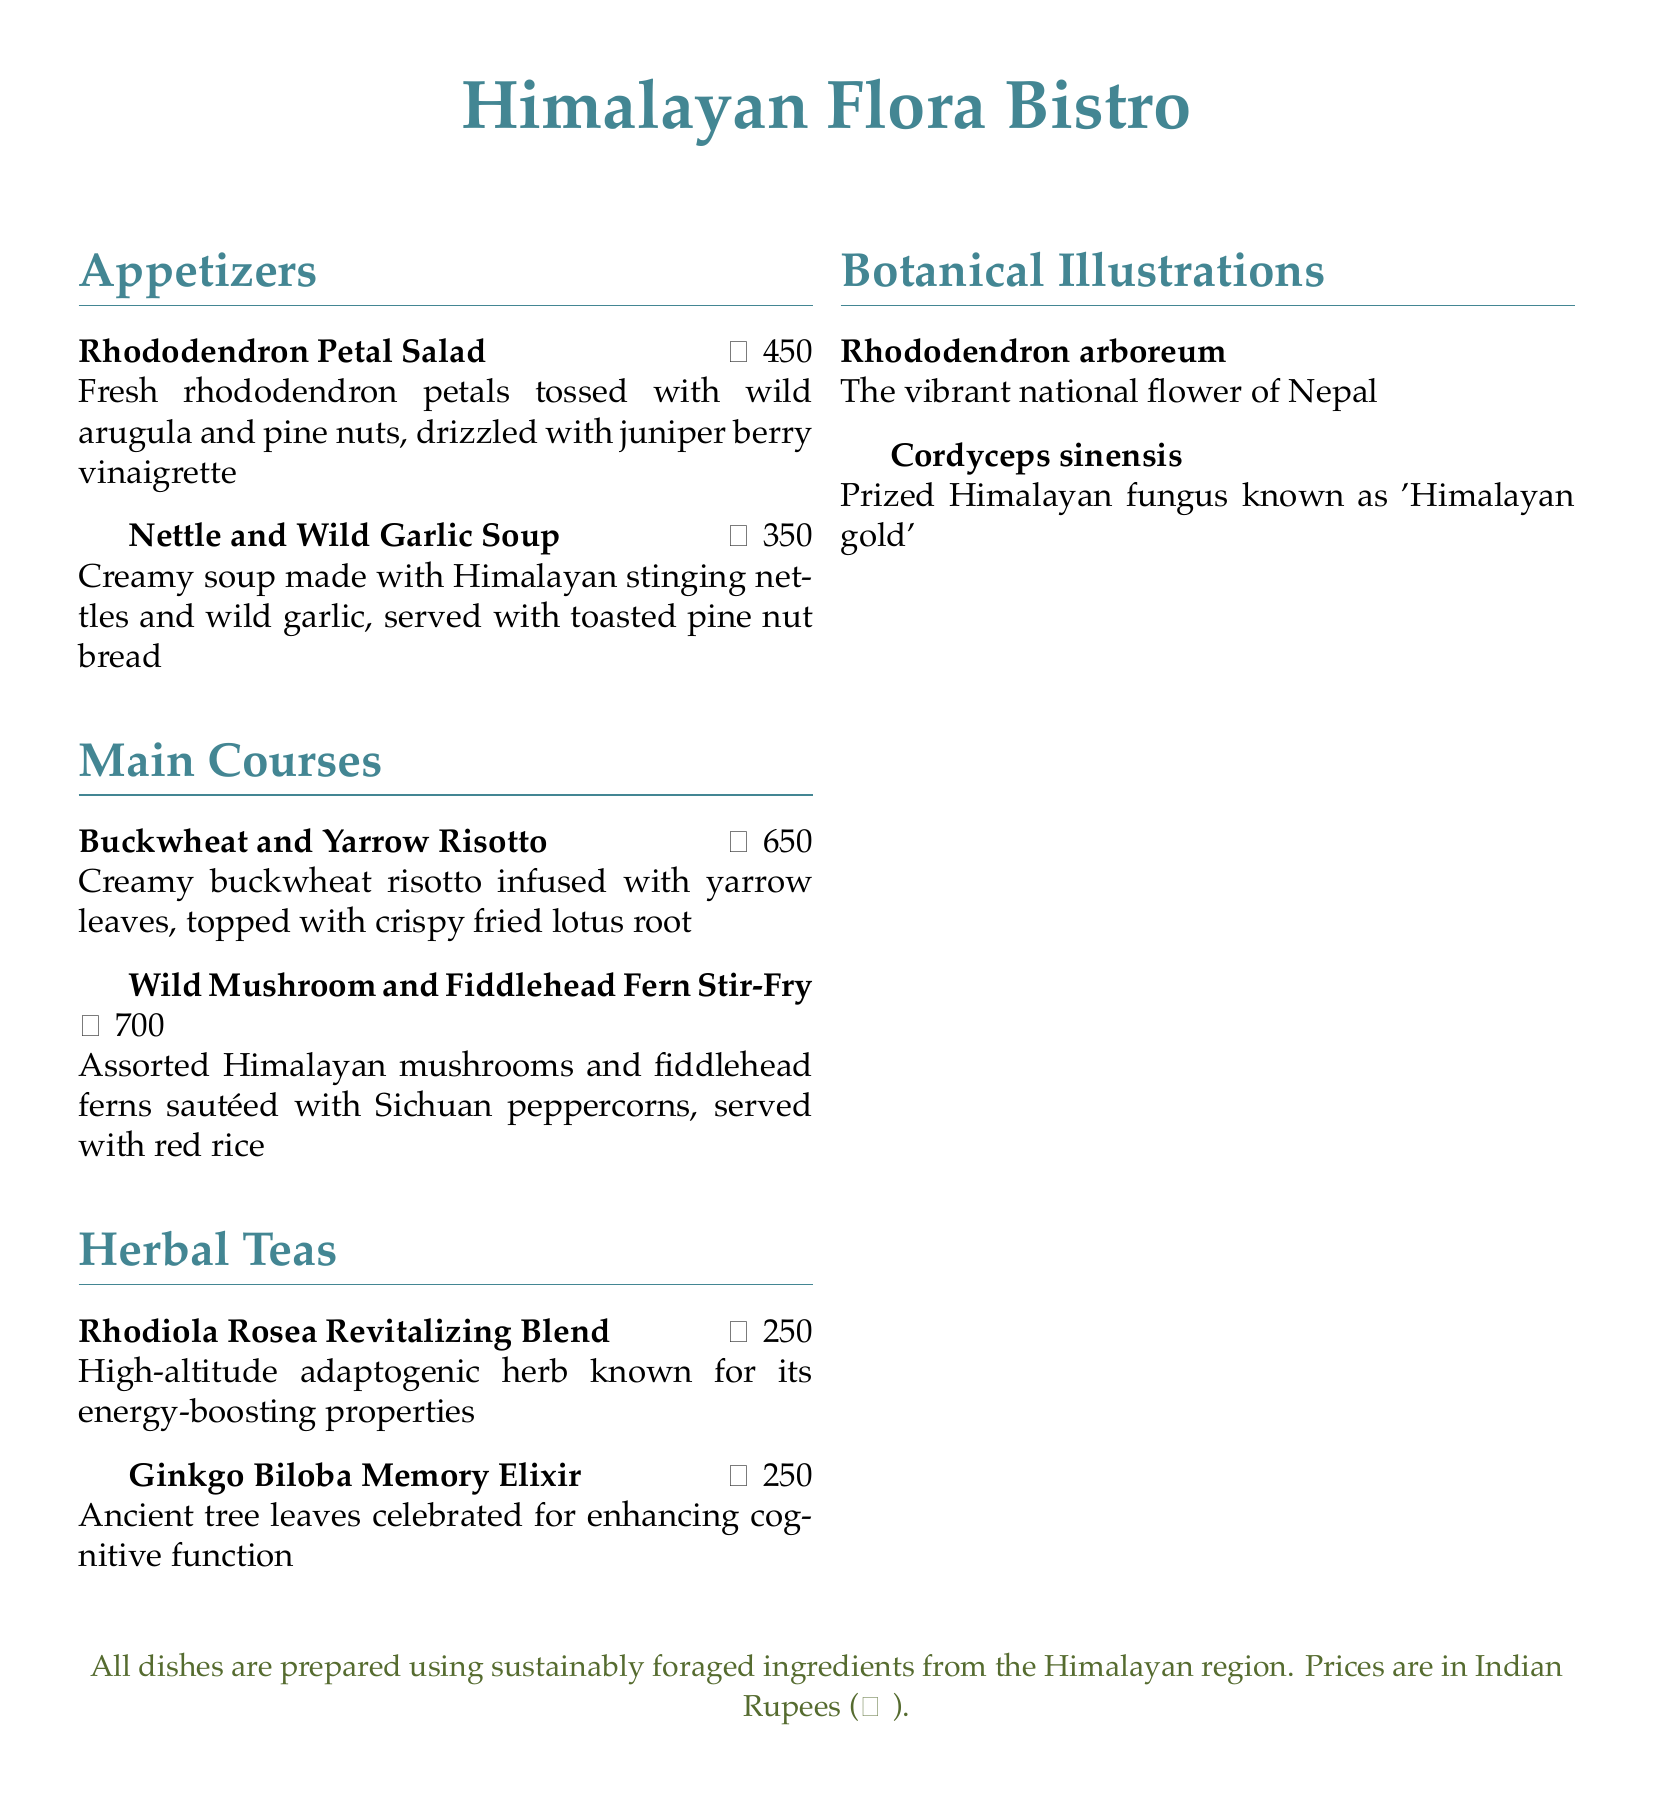What is the price of the Rhododendron Petal Salad? The price of the Rhododendron Petal Salad is stated directly on the menu.
Answer: ₹450 What ingredient is used in the Nettle and Wild Garlic Soup? The ingredient is mentioned in the description of the soup on the menu.
Answer: Himalayan stinging nettles What is the name of the tea known for energy-boosting properties? The tea's name is provided in the menu's herbal tea section.
Answer: Rhodiola Rosea Revitalizing Blend How much does the Wild Mushroom and Fiddlehead Fern Stir-Fry cost? The cost of the Wild Mushroom and Fiddlehead Fern Stir-Fry is listed in the main courses section.
Answer: ₹700 Which dish includes yarrow leaves? The dish that contains yarrow leaves is specified in the main courses.
Answer: Buckwheat and Yarrow Risotto What is the national flower of Nepal? The menu includes a section on botanical illustrations that states this information.
Answer: Rhododendron arboreum Which is the highest-priced item on the menu? The prices of each item are listed, and the highest can be identified from the main courses section.
Answer: Wild Mushroom and Fiddlehead Fern Stir-Fry What cuisine style does the menu represent? The presentation of dishes and ingredients indicates the type of cuisine in the title.
Answer: Himalayan-inspired vegetarian How many herbal teas are listed? The menu provides a count of items listed specifically in the herbal teas section.
Answer: 2 What type of bread is served with the Nettle and Wild Garlic Soup? The type of bread served is mentioned in the description of the soup.
Answer: Toasted pine nut bread 